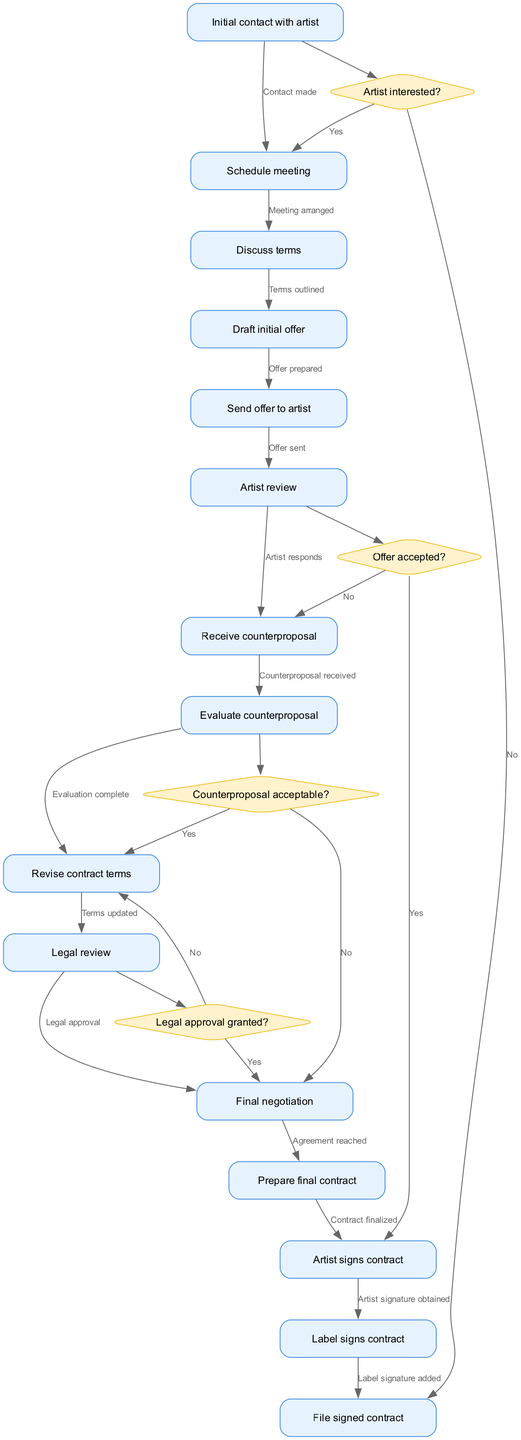What is the first step in the contract negotiation workflow? The diagram illustrates that the first step is "Initial contact with artist," which is represented as the starting node.
Answer: Initial contact with artist How many nodes are there in the diagram? By counting all the unique nodes present in the diagram, there are a total of 14 nodes that represent steps in the negotiation workflow.
Answer: 14 What happens after the artist reviews the offer? According to the flow, after the "Artist review" node, the next step is "Receive counterproposal," indicating that a counterproposal is expected from the artist.
Answer: Receive counterproposal Is there a decision required after receiving the counterproposal? Yes, the diagram shows a decision node labeled "Counterproposal acceptable?" indicating that a decision must be made before proceeding.
Answer: Yes What is the final step in this workflow? The workflow concludes with "File signed contract," which is the last node that indicates the completion of the contract process.
Answer: File signed contract If the artist is not interested, what is the outcome? The diagram allows for a flow where if the decision at the "Artist interested?" node is "No," it leads directly to the filing of the signed contract, indicating a negative outcome.
Answer: Contract filed What do you need to obtain from the artist to finalize the contract? To finalize the contract, the diagram specifies that you need to obtain the "Artist signs contract," which is a crucial step before further actions can take place.
Answer: Artist signs contract What decision occurs after the legal review? Following the "Legal review," the next step is the decision node labeled "Legal approval granted?" This indicates whether legal approval is obtained for the revised contract.
Answer: Legal approval granted? 